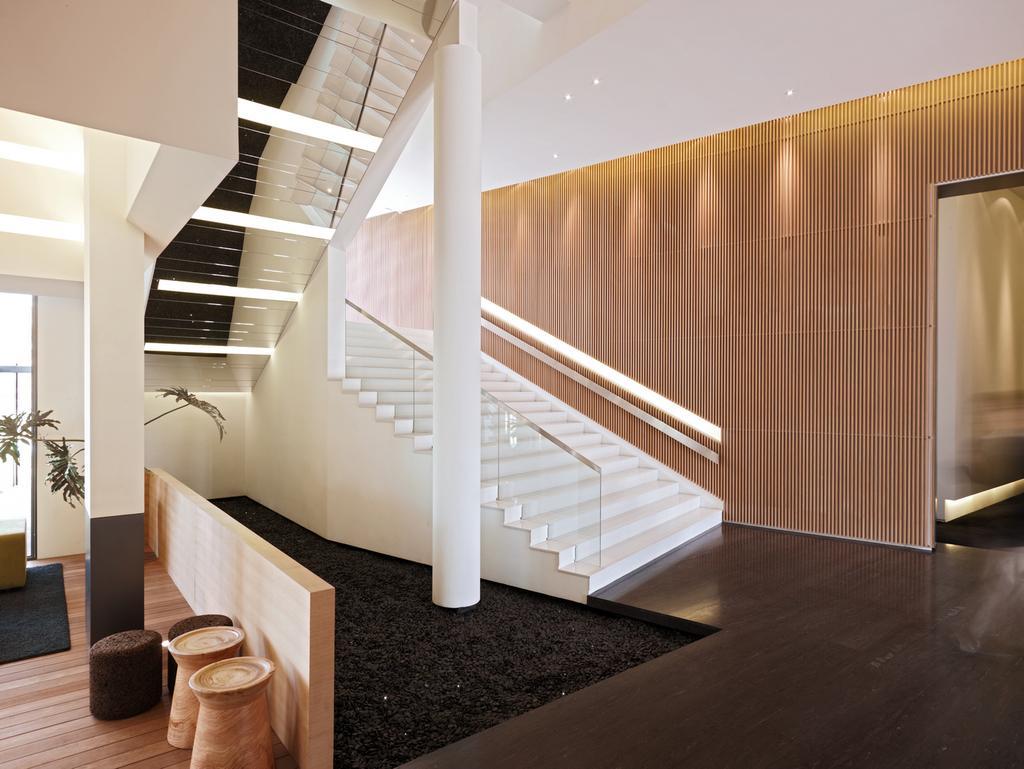In one or two sentences, can you explain what this image depicts? In this picture we can see a carpet on the floor, house plant, pillars, steps and in the background we can see the wall. 